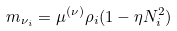<formula> <loc_0><loc_0><loc_500><loc_500>m _ { \nu _ { i } } = \mu ^ { ( \nu ) } \rho _ { i } ( 1 - \eta N ^ { 2 } _ { i } )</formula> 